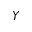<formula> <loc_0><loc_0><loc_500><loc_500>Y</formula> 